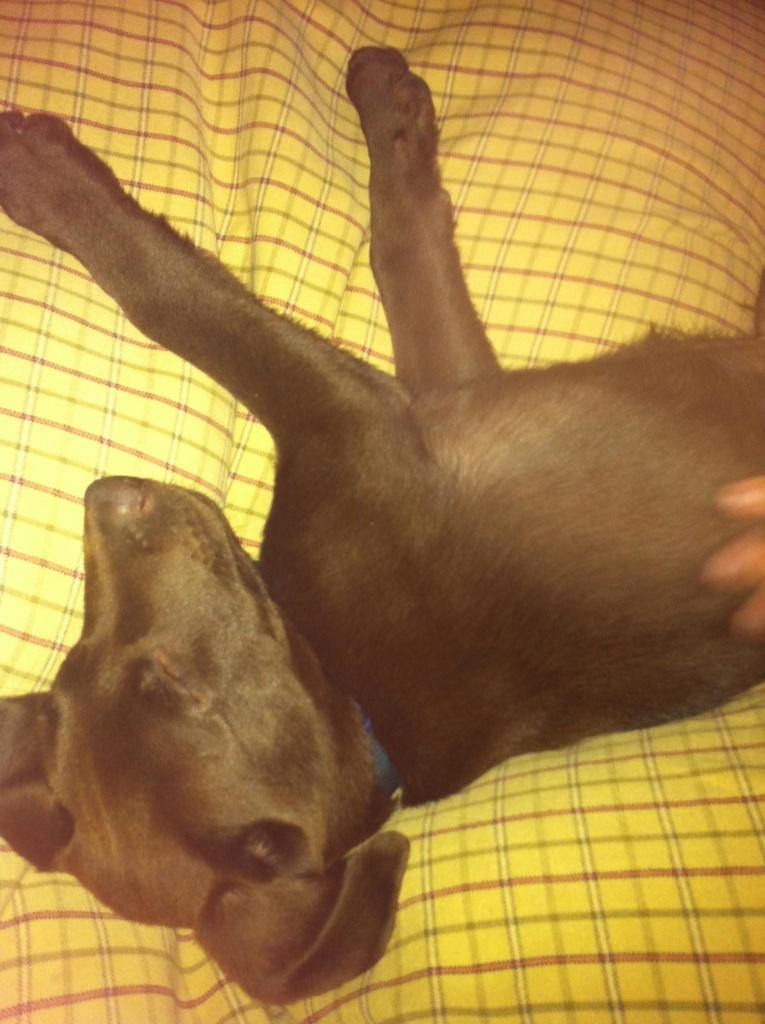What type of animal is present in the image? There is a black color dog in the image. What is the dog doing in the image? The dog is sleeping. What other object can be seen in the image besides the dog? There is a yellow color cloth in the image. Can you see any horns on the dog in the image? No, there are no horns visible on the dog in the image. What type of bird is sitting on the dog in the image? There is no bird, including a wren, present on the dog in the image. Are there any dinosaurs visible in the image? No, there are no dinosaurs visible in the image. 